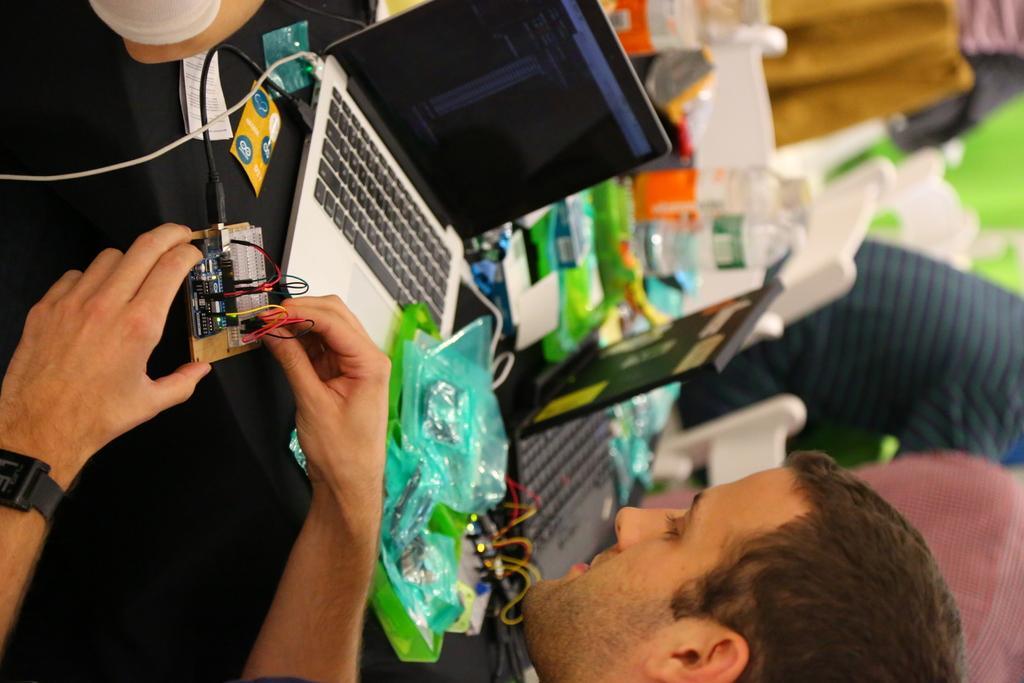Could you give a brief overview of what you see in this image? This is a rotated image. In this image there is a person holding an object in his hand, in front of him there is a table with some laptops, papers, books, bottles and some other objects, beside the table there are a few people sitting on their chairs. 